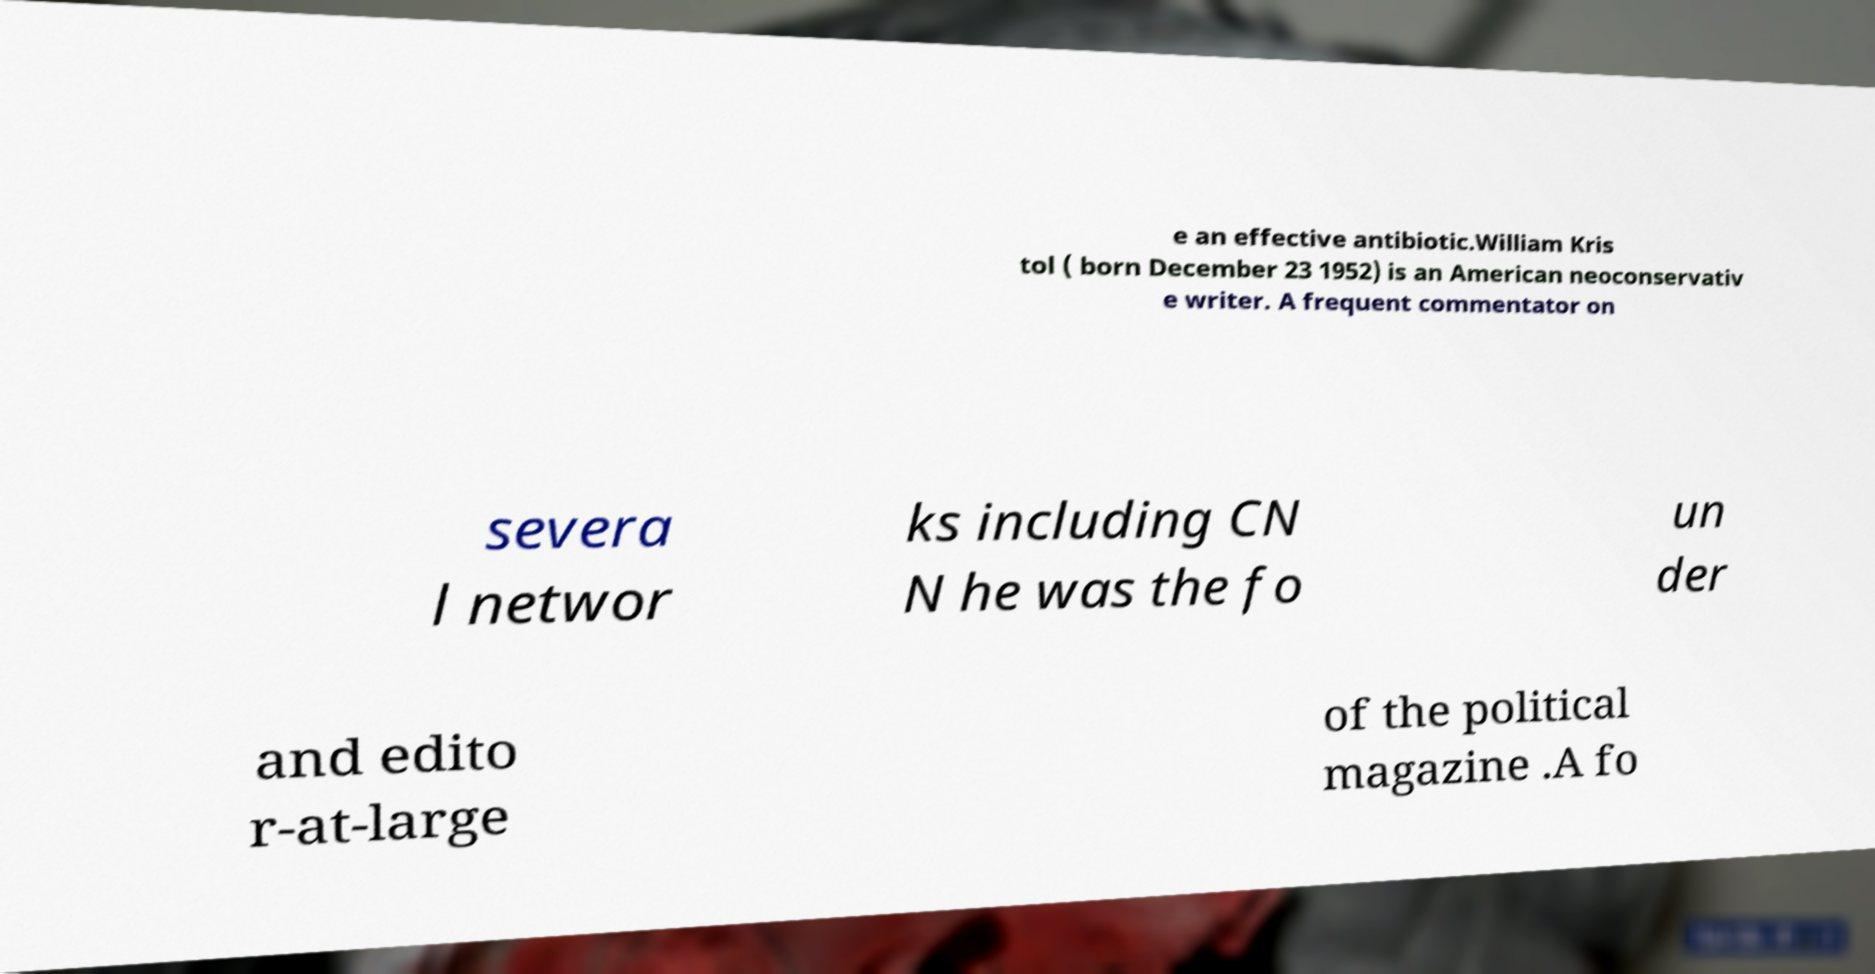What messages or text are displayed in this image? I need them in a readable, typed format. e an effective antibiotic.William Kris tol ( born December 23 1952) is an American neoconservativ e writer. A frequent commentator on severa l networ ks including CN N he was the fo un der and edito r-at-large of the political magazine .A fo 